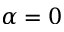Convert formula to latex. <formula><loc_0><loc_0><loc_500><loc_500>\alpha = 0</formula> 